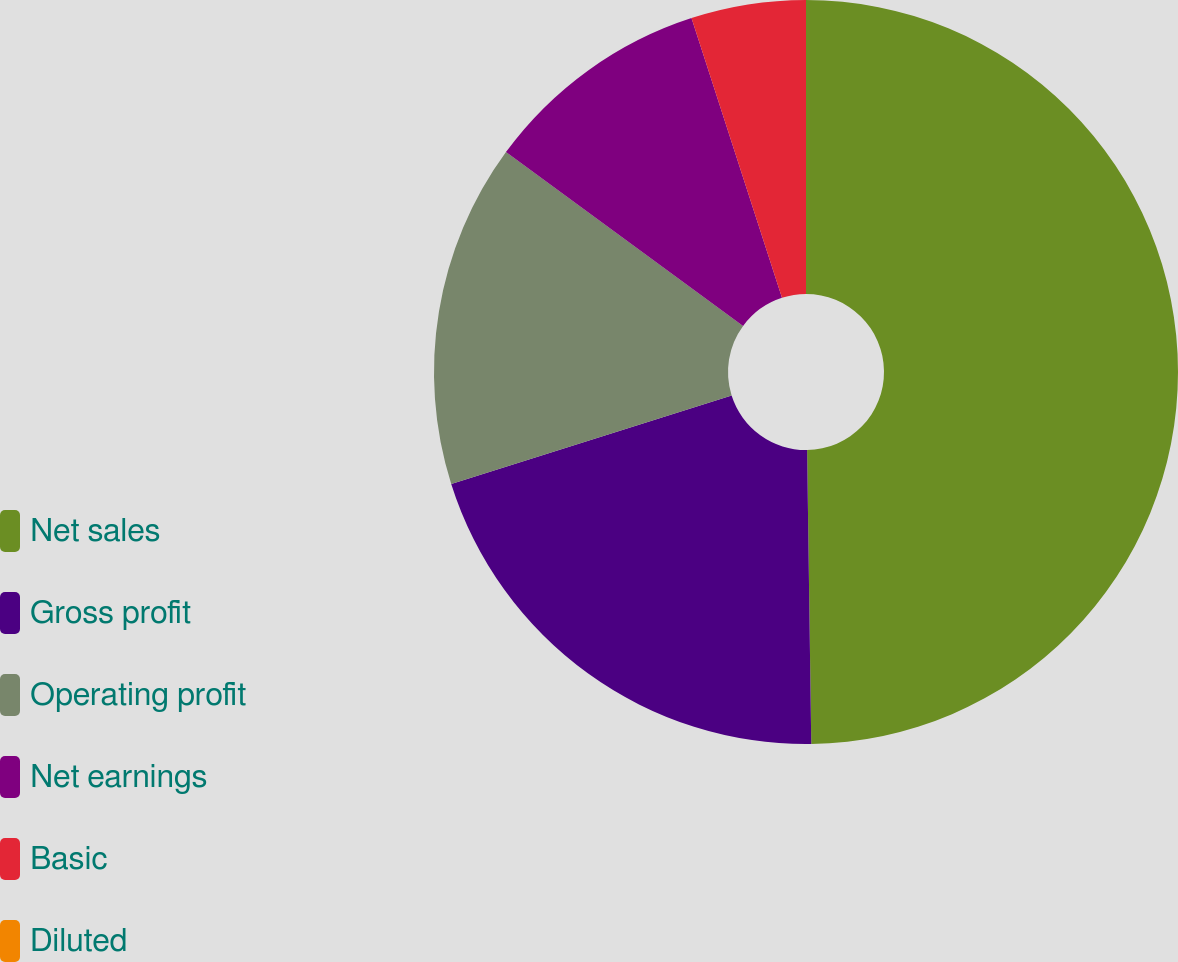Convert chart to OTSL. <chart><loc_0><loc_0><loc_500><loc_500><pie_chart><fcel>Net sales<fcel>Gross profit<fcel>Operating profit<fcel>Net earnings<fcel>Basic<fcel>Diluted<nl><fcel>49.77%<fcel>20.36%<fcel>14.93%<fcel>9.95%<fcel>4.98%<fcel>0.0%<nl></chart> 